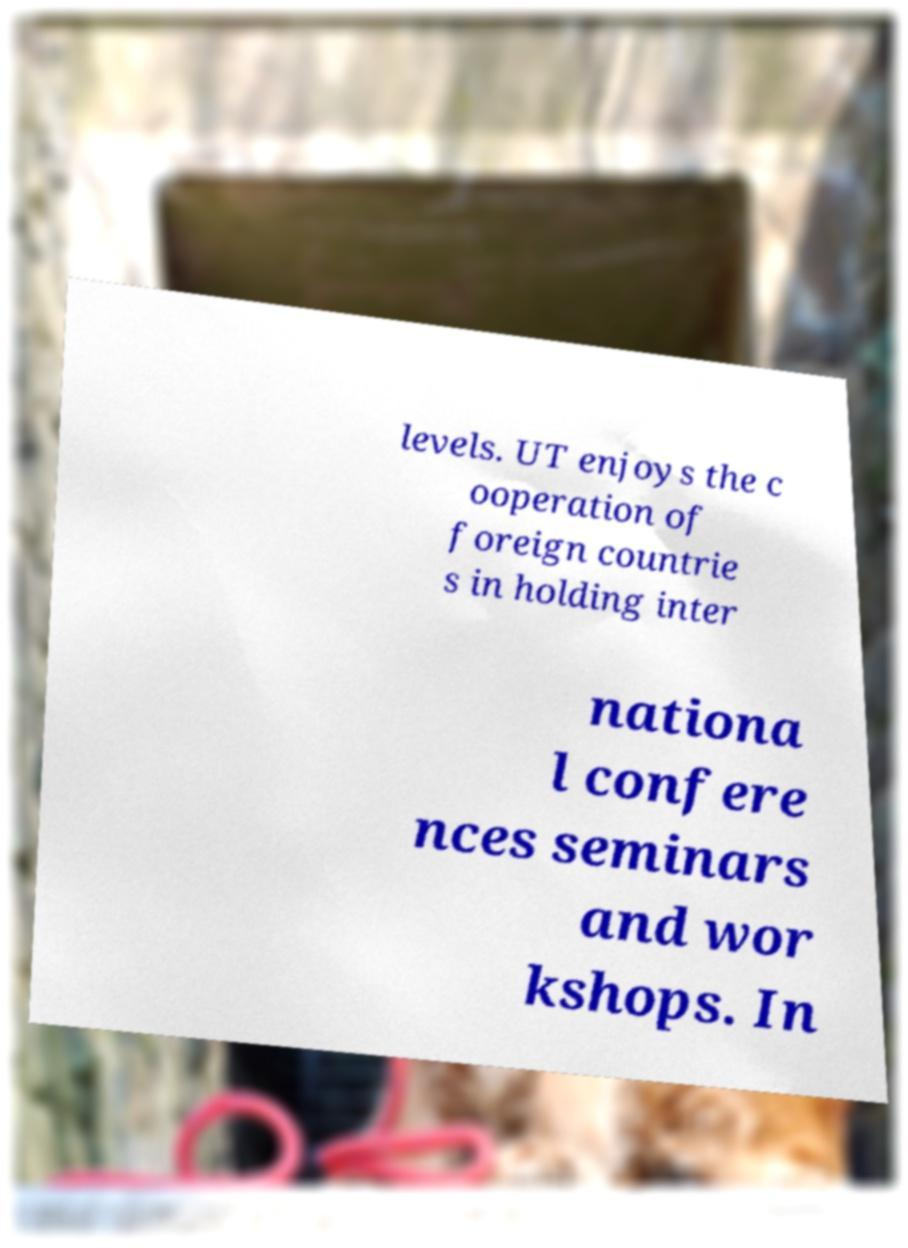Please read and relay the text visible in this image. What does it say? levels. UT enjoys the c ooperation of foreign countrie s in holding inter nationa l confere nces seminars and wor kshops. In 